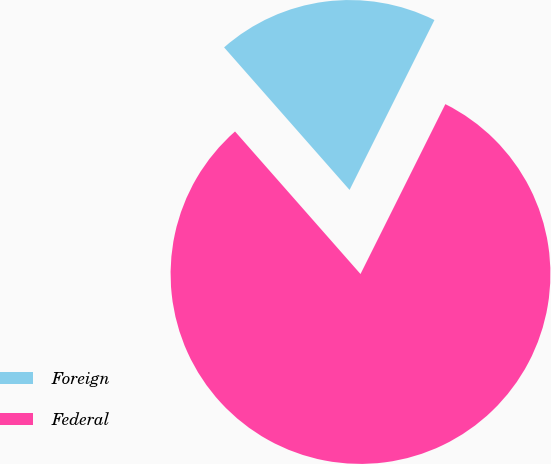Convert chart. <chart><loc_0><loc_0><loc_500><loc_500><pie_chart><fcel>Foreign<fcel>Federal<nl><fcel>18.86%<fcel>81.14%<nl></chart> 